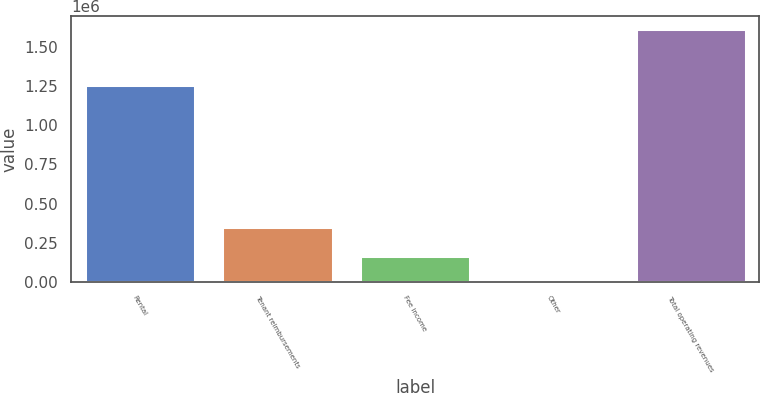<chart> <loc_0><loc_0><loc_500><loc_500><bar_chart><fcel>Rental<fcel>Tenant reimbursements<fcel>Fee income<fcel>Other<fcel>Total operating revenues<nl><fcel>1.25609e+06<fcel>350234<fcel>164209<fcel>2850<fcel>1.61644e+06<nl></chart> 